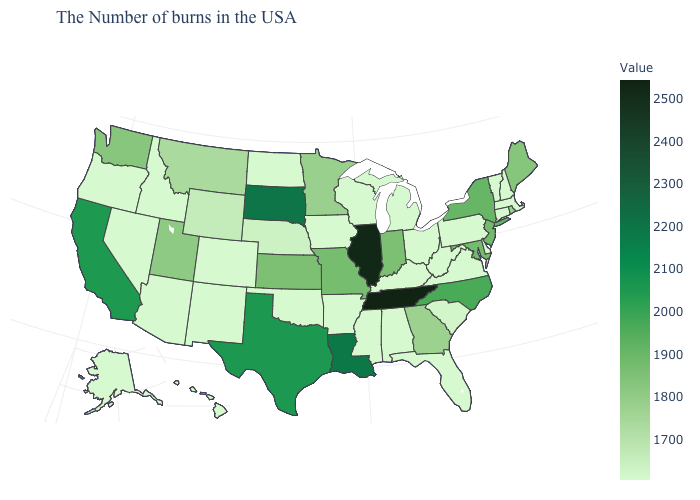Among the states that border Rhode Island , which have the lowest value?
Concise answer only. Massachusetts, Connecticut. Does Tennessee have the highest value in the South?
Short answer required. Yes. Among the states that border Nebraska , does South Dakota have the highest value?
Be succinct. Yes. Which states have the highest value in the USA?
Short answer required. Tennessee. 